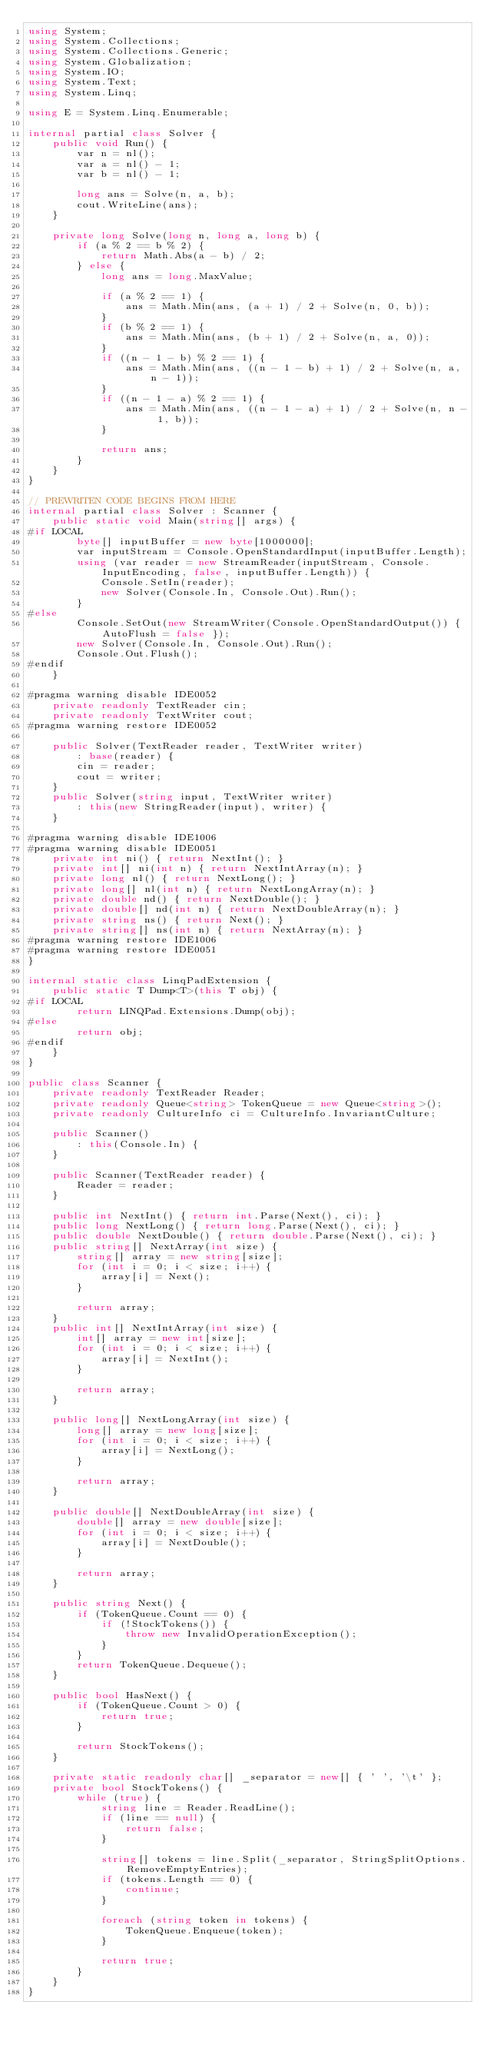Convert code to text. <code><loc_0><loc_0><loc_500><loc_500><_C#_>using System;
using System.Collections;
using System.Collections.Generic;
using System.Globalization;
using System.IO;
using System.Text;
using System.Linq;

using E = System.Linq.Enumerable;

internal partial class Solver {
    public void Run() {
        var n = nl();
        var a = nl() - 1;
        var b = nl() - 1;

        long ans = Solve(n, a, b);
        cout.WriteLine(ans);
    }

    private long Solve(long n, long a, long b) {
        if (a % 2 == b % 2) {
            return Math.Abs(a - b) / 2;
        } else {
            long ans = long.MaxValue;

            if (a % 2 == 1) {
                ans = Math.Min(ans, (a + 1) / 2 + Solve(n, 0, b));
            }
            if (b % 2 == 1) {
                ans = Math.Min(ans, (b + 1) / 2 + Solve(n, a, 0));
            }
            if ((n - 1 - b) % 2 == 1) {
                ans = Math.Min(ans, ((n - 1 - b) + 1) / 2 + Solve(n, a, n - 1));
            }
            if ((n - 1 - a) % 2 == 1) {
                ans = Math.Min(ans, ((n - 1 - a) + 1) / 2 + Solve(n, n - 1, b));
            }

            return ans;
        }
    }
}

// PREWRITEN CODE BEGINS FROM HERE
internal partial class Solver : Scanner {
    public static void Main(string[] args) {
#if LOCAL
        byte[] inputBuffer = new byte[1000000];
        var inputStream = Console.OpenStandardInput(inputBuffer.Length);
        using (var reader = new StreamReader(inputStream, Console.InputEncoding, false, inputBuffer.Length)) {
            Console.SetIn(reader);
            new Solver(Console.In, Console.Out).Run();
        }
#else
        Console.SetOut(new StreamWriter(Console.OpenStandardOutput()) { AutoFlush = false });
        new Solver(Console.In, Console.Out).Run();
        Console.Out.Flush();
#endif
    }

#pragma warning disable IDE0052
    private readonly TextReader cin;
    private readonly TextWriter cout;
#pragma warning restore IDE0052

    public Solver(TextReader reader, TextWriter writer)
        : base(reader) {
        cin = reader;
        cout = writer;
    }
    public Solver(string input, TextWriter writer)
        : this(new StringReader(input), writer) {
    }

#pragma warning disable IDE1006
#pragma warning disable IDE0051
    private int ni() { return NextInt(); }
    private int[] ni(int n) { return NextIntArray(n); }
    private long nl() { return NextLong(); }
    private long[] nl(int n) { return NextLongArray(n); }
    private double nd() { return NextDouble(); }
    private double[] nd(int n) { return NextDoubleArray(n); }
    private string ns() { return Next(); }
    private string[] ns(int n) { return NextArray(n); }
#pragma warning restore IDE1006
#pragma warning restore IDE0051
}

internal static class LinqPadExtension {
    public static T Dump<T>(this T obj) {
#if LOCAL
        return LINQPad.Extensions.Dump(obj);
#else
        return obj;
#endif
    }
}

public class Scanner {
    private readonly TextReader Reader;
    private readonly Queue<string> TokenQueue = new Queue<string>();
    private readonly CultureInfo ci = CultureInfo.InvariantCulture;

    public Scanner()
        : this(Console.In) {
    }

    public Scanner(TextReader reader) {
        Reader = reader;
    }

    public int NextInt() { return int.Parse(Next(), ci); }
    public long NextLong() { return long.Parse(Next(), ci); }
    public double NextDouble() { return double.Parse(Next(), ci); }
    public string[] NextArray(int size) {
        string[] array = new string[size];
        for (int i = 0; i < size; i++) {
            array[i] = Next();
        }

        return array;
    }
    public int[] NextIntArray(int size) {
        int[] array = new int[size];
        for (int i = 0; i < size; i++) {
            array[i] = NextInt();
        }

        return array;
    }

    public long[] NextLongArray(int size) {
        long[] array = new long[size];
        for (int i = 0; i < size; i++) {
            array[i] = NextLong();
        }

        return array;
    }

    public double[] NextDoubleArray(int size) {
        double[] array = new double[size];
        for (int i = 0; i < size; i++) {
            array[i] = NextDouble();
        }

        return array;
    }

    public string Next() {
        if (TokenQueue.Count == 0) {
            if (!StockTokens()) {
                throw new InvalidOperationException();
            }
        }
        return TokenQueue.Dequeue();
    }

    public bool HasNext() {
        if (TokenQueue.Count > 0) {
            return true;
        }

        return StockTokens();
    }

    private static readonly char[] _separator = new[] { ' ', '\t' };
    private bool StockTokens() {
        while (true) {
            string line = Reader.ReadLine();
            if (line == null) {
                return false;
            }

            string[] tokens = line.Split(_separator, StringSplitOptions.RemoveEmptyEntries);
            if (tokens.Length == 0) {
                continue;
            }

            foreach (string token in tokens) {
                TokenQueue.Enqueue(token);
            }

            return true;
        }
    }
}
</code> 